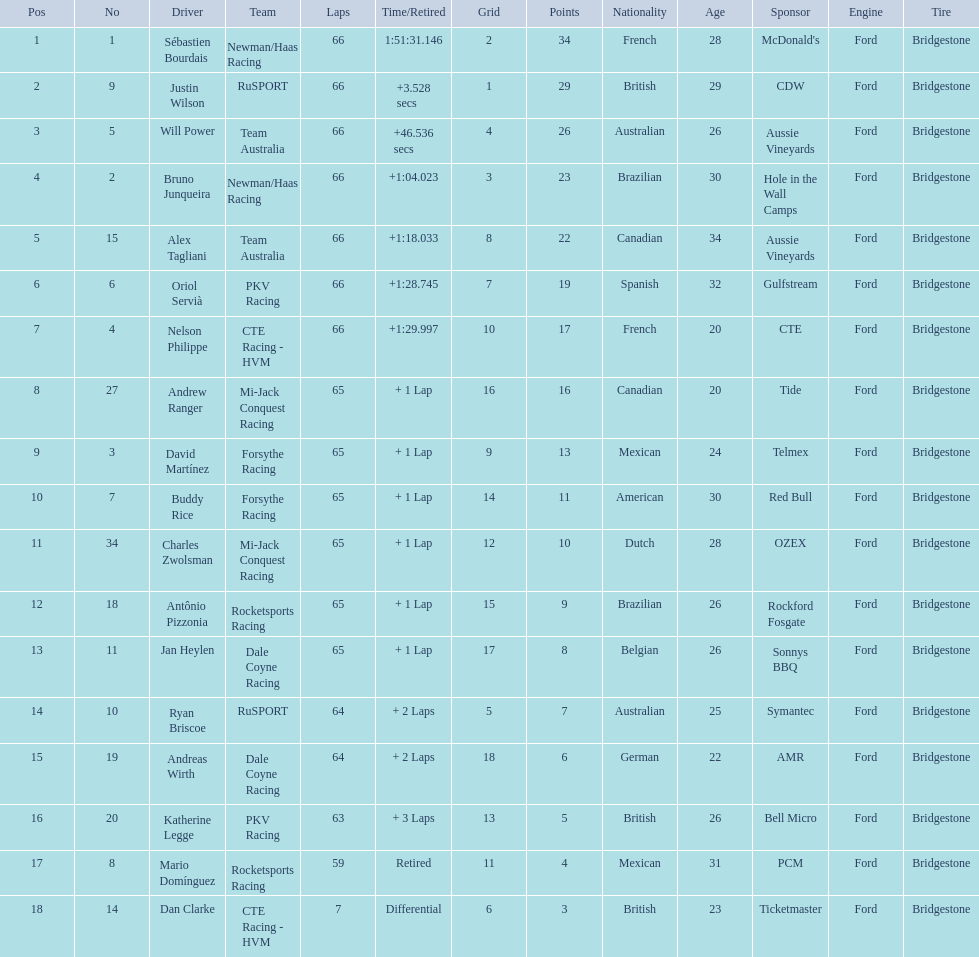What drivers started in the top 10? Sébastien Bourdais, Justin Wilson, Will Power, Bruno Junqueira, Alex Tagliani, Oriol Servià, Nelson Philippe, Ryan Briscoe, Dan Clarke. Which of those drivers completed all 66 laps? Sébastien Bourdais, Justin Wilson, Will Power, Bruno Junqueira, Alex Tagliani, Oriol Servià, Nelson Philippe. Whom of these did not drive for team australia? Sébastien Bourdais, Justin Wilson, Bruno Junqueira, Oriol Servià, Nelson Philippe. Which of these drivers finished more then a minuet after the winner? Bruno Junqueira, Oriol Servià, Nelson Philippe. Which of these drivers had the highest car number? Oriol Servià. How many laps did oriol servia complete at the 2006 gran premio? 66. How many laps did katherine legge complete at the 2006 gran premio? 63. Between servia and legge, who completed more laps? Oriol Servià. 